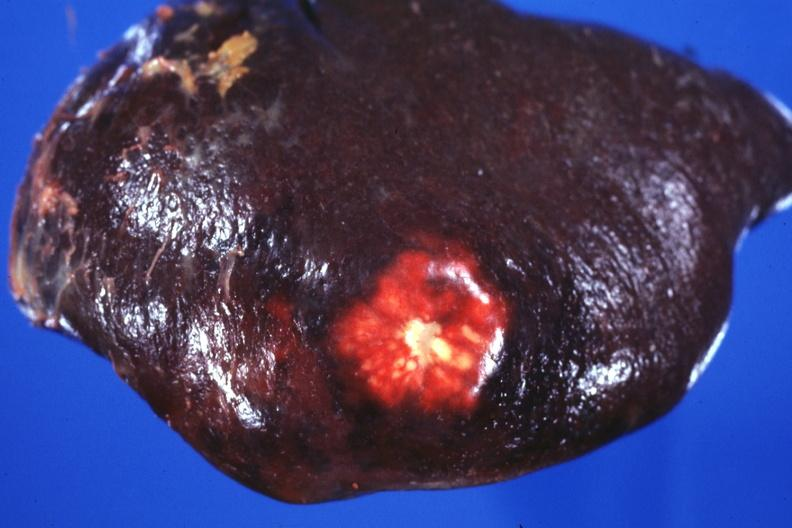s marked present?
Answer the question using a single word or phrase. No 